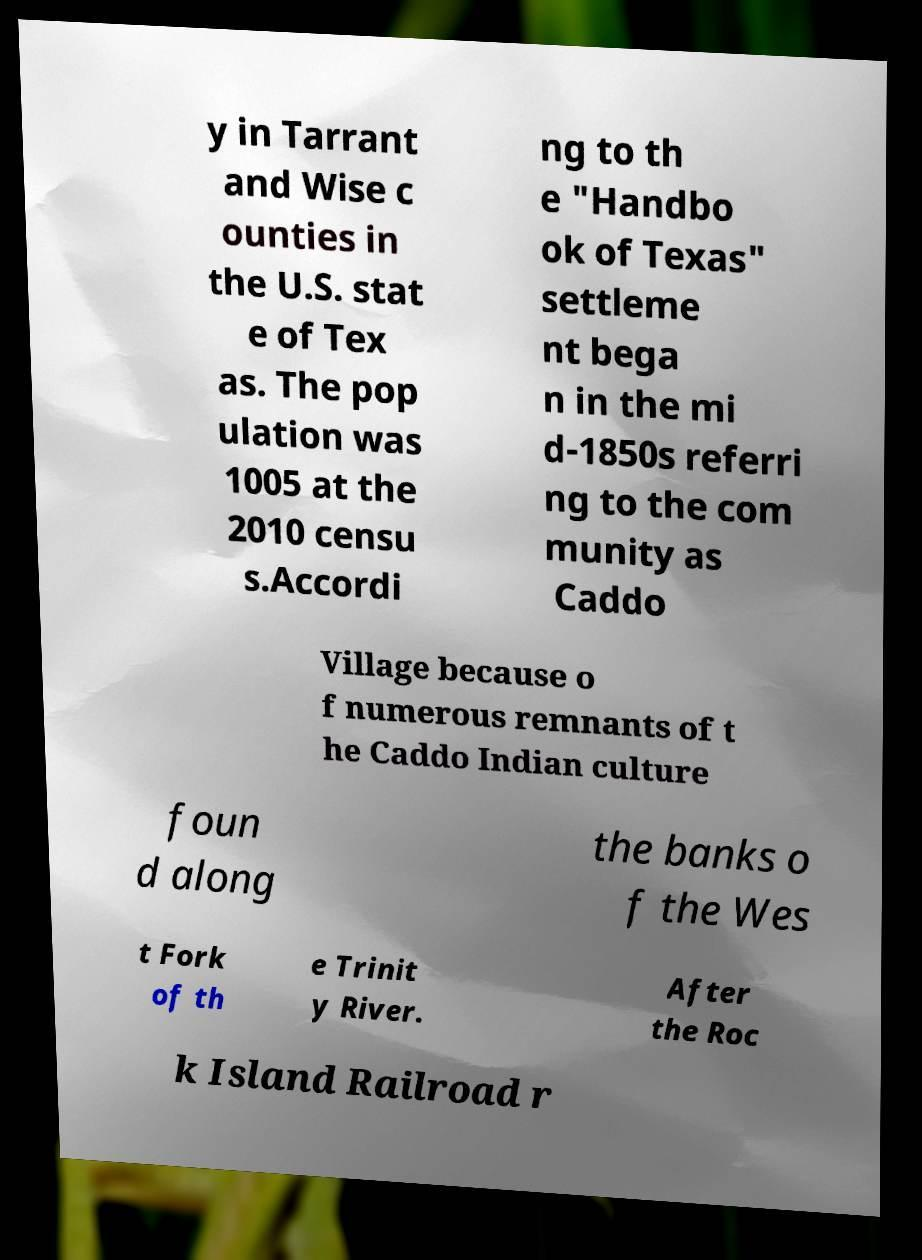There's text embedded in this image that I need extracted. Can you transcribe it verbatim? y in Tarrant and Wise c ounties in the U.S. stat e of Tex as. The pop ulation was 1005 at the 2010 censu s.Accordi ng to th e "Handbo ok of Texas" settleme nt bega n in the mi d-1850s referri ng to the com munity as Caddo Village because o f numerous remnants of t he Caddo Indian culture foun d along the banks o f the Wes t Fork of th e Trinit y River. After the Roc k Island Railroad r 